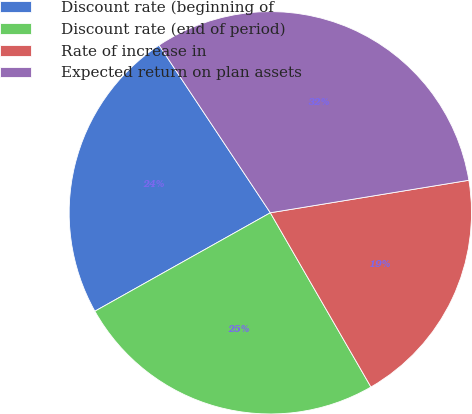<chart> <loc_0><loc_0><loc_500><loc_500><pie_chart><fcel>Discount rate (beginning of<fcel>Discount rate (end of period)<fcel>Rate of increase in<fcel>Expected return on plan assets<nl><fcel>23.81%<fcel>25.2%<fcel>19.25%<fcel>31.75%<nl></chart> 